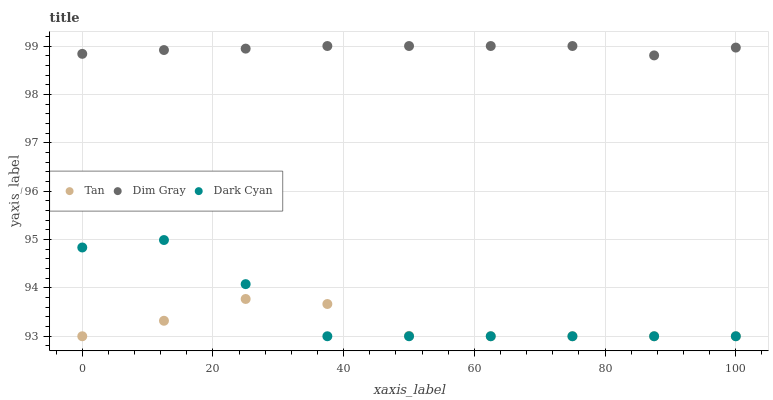Does Tan have the minimum area under the curve?
Answer yes or no. Yes. Does Dim Gray have the maximum area under the curve?
Answer yes or no. Yes. Does Dim Gray have the minimum area under the curve?
Answer yes or no. No. Does Tan have the maximum area under the curve?
Answer yes or no. No. Is Dim Gray the smoothest?
Answer yes or no. Yes. Is Dark Cyan the roughest?
Answer yes or no. Yes. Is Tan the smoothest?
Answer yes or no. No. Is Tan the roughest?
Answer yes or no. No. Does Dark Cyan have the lowest value?
Answer yes or no. Yes. Does Dim Gray have the lowest value?
Answer yes or no. No. Does Dim Gray have the highest value?
Answer yes or no. Yes. Does Tan have the highest value?
Answer yes or no. No. Is Tan less than Dim Gray?
Answer yes or no. Yes. Is Dim Gray greater than Tan?
Answer yes or no. Yes. Does Dark Cyan intersect Tan?
Answer yes or no. Yes. Is Dark Cyan less than Tan?
Answer yes or no. No. Is Dark Cyan greater than Tan?
Answer yes or no. No. Does Tan intersect Dim Gray?
Answer yes or no. No. 